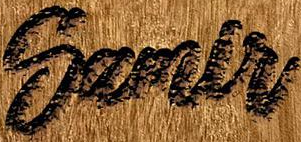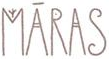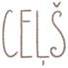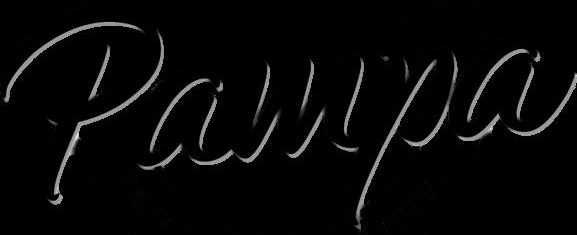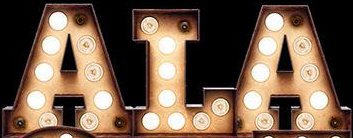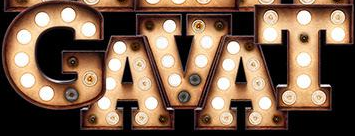Identify the words shown in these images in order, separated by a semicolon. Samlr; MĀRAS; CEḶŠ; Pampa; ALA; GAVAT 